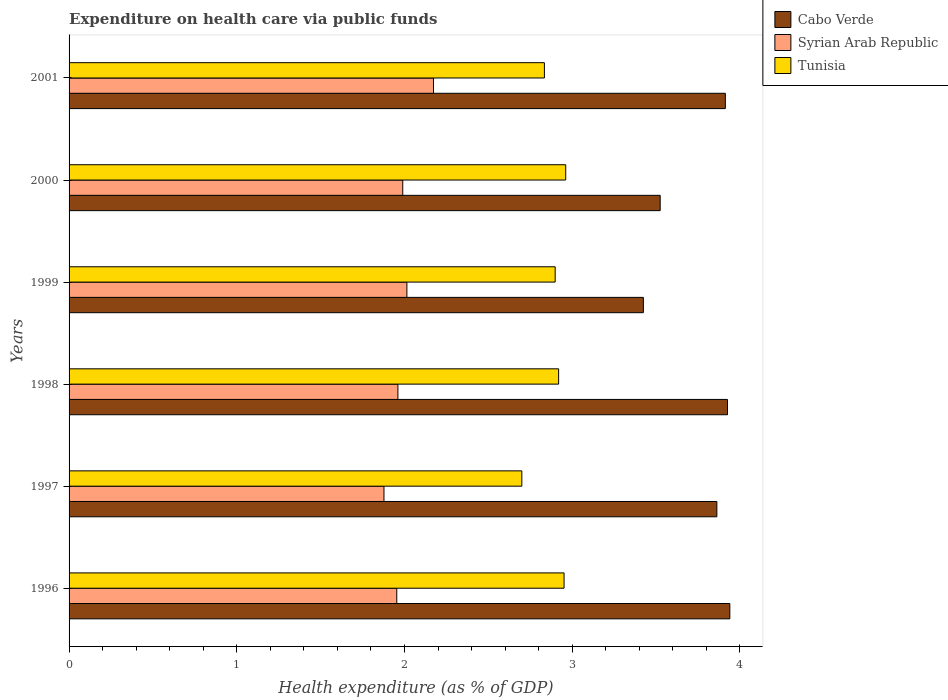How many different coloured bars are there?
Your answer should be very brief. 3. How many bars are there on the 1st tick from the top?
Your response must be concise. 3. How many bars are there on the 2nd tick from the bottom?
Offer a terse response. 3. What is the label of the 1st group of bars from the top?
Your answer should be compact. 2001. In how many cases, is the number of bars for a given year not equal to the number of legend labels?
Offer a very short reply. 0. What is the expenditure made on health care in Syrian Arab Republic in 2000?
Your response must be concise. 1.99. Across all years, what is the maximum expenditure made on health care in Tunisia?
Your response must be concise. 2.96. Across all years, what is the minimum expenditure made on health care in Tunisia?
Offer a terse response. 2.7. In which year was the expenditure made on health care in Cabo Verde maximum?
Ensure brevity in your answer.  1996. What is the total expenditure made on health care in Tunisia in the graph?
Provide a short and direct response. 17.27. What is the difference between the expenditure made on health care in Cabo Verde in 2000 and that in 2001?
Offer a very short reply. -0.39. What is the difference between the expenditure made on health care in Syrian Arab Republic in 2000 and the expenditure made on health care in Cabo Verde in 2001?
Offer a very short reply. -1.92. What is the average expenditure made on health care in Cabo Verde per year?
Your response must be concise. 3.77. In the year 2001, what is the difference between the expenditure made on health care in Cabo Verde and expenditure made on health care in Syrian Arab Republic?
Offer a terse response. 1.74. What is the ratio of the expenditure made on health care in Tunisia in 1996 to that in 1999?
Offer a terse response. 1.02. Is the difference between the expenditure made on health care in Cabo Verde in 1996 and 2000 greater than the difference between the expenditure made on health care in Syrian Arab Republic in 1996 and 2000?
Keep it short and to the point. Yes. What is the difference between the highest and the second highest expenditure made on health care in Tunisia?
Provide a succinct answer. 0.01. What is the difference between the highest and the lowest expenditure made on health care in Syrian Arab Republic?
Give a very brief answer. 0.3. What does the 2nd bar from the top in 1998 represents?
Make the answer very short. Syrian Arab Republic. What does the 3rd bar from the bottom in 2000 represents?
Offer a terse response. Tunisia. What is the difference between two consecutive major ticks on the X-axis?
Your answer should be compact. 1. Are the values on the major ticks of X-axis written in scientific E-notation?
Provide a short and direct response. No. Does the graph contain any zero values?
Provide a succinct answer. No. Where does the legend appear in the graph?
Offer a very short reply. Top right. How many legend labels are there?
Offer a terse response. 3. How are the legend labels stacked?
Offer a terse response. Vertical. What is the title of the graph?
Provide a short and direct response. Expenditure on health care via public funds. What is the label or title of the X-axis?
Provide a succinct answer. Health expenditure (as % of GDP). What is the label or title of the Y-axis?
Your answer should be very brief. Years. What is the Health expenditure (as % of GDP) in Cabo Verde in 1996?
Offer a very short reply. 3.94. What is the Health expenditure (as % of GDP) of Syrian Arab Republic in 1996?
Provide a succinct answer. 1.95. What is the Health expenditure (as % of GDP) of Tunisia in 1996?
Your answer should be very brief. 2.95. What is the Health expenditure (as % of GDP) of Cabo Verde in 1997?
Ensure brevity in your answer.  3.86. What is the Health expenditure (as % of GDP) of Syrian Arab Republic in 1997?
Offer a very short reply. 1.88. What is the Health expenditure (as % of GDP) in Tunisia in 1997?
Give a very brief answer. 2.7. What is the Health expenditure (as % of GDP) of Cabo Verde in 1998?
Make the answer very short. 3.93. What is the Health expenditure (as % of GDP) in Syrian Arab Republic in 1998?
Give a very brief answer. 1.96. What is the Health expenditure (as % of GDP) in Tunisia in 1998?
Offer a terse response. 2.92. What is the Health expenditure (as % of GDP) of Cabo Verde in 1999?
Offer a very short reply. 3.42. What is the Health expenditure (as % of GDP) in Syrian Arab Republic in 1999?
Your answer should be compact. 2.01. What is the Health expenditure (as % of GDP) of Tunisia in 1999?
Offer a terse response. 2.9. What is the Health expenditure (as % of GDP) in Cabo Verde in 2000?
Make the answer very short. 3.52. What is the Health expenditure (as % of GDP) in Syrian Arab Republic in 2000?
Your response must be concise. 1.99. What is the Health expenditure (as % of GDP) in Tunisia in 2000?
Your answer should be very brief. 2.96. What is the Health expenditure (as % of GDP) in Cabo Verde in 2001?
Provide a succinct answer. 3.91. What is the Health expenditure (as % of GDP) of Syrian Arab Republic in 2001?
Provide a succinct answer. 2.17. What is the Health expenditure (as % of GDP) of Tunisia in 2001?
Your response must be concise. 2.83. Across all years, what is the maximum Health expenditure (as % of GDP) in Cabo Verde?
Your response must be concise. 3.94. Across all years, what is the maximum Health expenditure (as % of GDP) in Syrian Arab Republic?
Give a very brief answer. 2.17. Across all years, what is the maximum Health expenditure (as % of GDP) of Tunisia?
Ensure brevity in your answer.  2.96. Across all years, what is the minimum Health expenditure (as % of GDP) of Cabo Verde?
Ensure brevity in your answer.  3.42. Across all years, what is the minimum Health expenditure (as % of GDP) of Syrian Arab Republic?
Offer a very short reply. 1.88. Across all years, what is the minimum Health expenditure (as % of GDP) of Tunisia?
Provide a succinct answer. 2.7. What is the total Health expenditure (as % of GDP) in Cabo Verde in the graph?
Your response must be concise. 22.59. What is the total Health expenditure (as % of GDP) of Syrian Arab Republic in the graph?
Ensure brevity in your answer.  11.97. What is the total Health expenditure (as % of GDP) of Tunisia in the graph?
Provide a short and direct response. 17.27. What is the difference between the Health expenditure (as % of GDP) of Cabo Verde in 1996 and that in 1997?
Offer a terse response. 0.08. What is the difference between the Health expenditure (as % of GDP) of Syrian Arab Republic in 1996 and that in 1997?
Your answer should be very brief. 0.08. What is the difference between the Health expenditure (as % of GDP) in Tunisia in 1996 and that in 1997?
Make the answer very short. 0.25. What is the difference between the Health expenditure (as % of GDP) in Cabo Verde in 1996 and that in 1998?
Keep it short and to the point. 0.01. What is the difference between the Health expenditure (as % of GDP) of Syrian Arab Republic in 1996 and that in 1998?
Offer a very short reply. -0.01. What is the difference between the Health expenditure (as % of GDP) of Tunisia in 1996 and that in 1998?
Your answer should be very brief. 0.03. What is the difference between the Health expenditure (as % of GDP) in Cabo Verde in 1996 and that in 1999?
Your response must be concise. 0.52. What is the difference between the Health expenditure (as % of GDP) in Syrian Arab Republic in 1996 and that in 1999?
Offer a very short reply. -0.06. What is the difference between the Health expenditure (as % of GDP) in Tunisia in 1996 and that in 1999?
Offer a very short reply. 0.05. What is the difference between the Health expenditure (as % of GDP) in Cabo Verde in 1996 and that in 2000?
Give a very brief answer. 0.42. What is the difference between the Health expenditure (as % of GDP) in Syrian Arab Republic in 1996 and that in 2000?
Your response must be concise. -0.04. What is the difference between the Health expenditure (as % of GDP) of Tunisia in 1996 and that in 2000?
Provide a succinct answer. -0.01. What is the difference between the Health expenditure (as % of GDP) in Cabo Verde in 1996 and that in 2001?
Offer a very short reply. 0.03. What is the difference between the Health expenditure (as % of GDP) of Syrian Arab Republic in 1996 and that in 2001?
Your response must be concise. -0.22. What is the difference between the Health expenditure (as % of GDP) of Tunisia in 1996 and that in 2001?
Ensure brevity in your answer.  0.12. What is the difference between the Health expenditure (as % of GDP) in Cabo Verde in 1997 and that in 1998?
Ensure brevity in your answer.  -0.06. What is the difference between the Health expenditure (as % of GDP) in Syrian Arab Republic in 1997 and that in 1998?
Your response must be concise. -0.08. What is the difference between the Health expenditure (as % of GDP) of Tunisia in 1997 and that in 1998?
Make the answer very short. -0.22. What is the difference between the Health expenditure (as % of GDP) of Cabo Verde in 1997 and that in 1999?
Your response must be concise. 0.44. What is the difference between the Health expenditure (as % of GDP) in Syrian Arab Republic in 1997 and that in 1999?
Give a very brief answer. -0.14. What is the difference between the Health expenditure (as % of GDP) in Tunisia in 1997 and that in 1999?
Ensure brevity in your answer.  -0.2. What is the difference between the Health expenditure (as % of GDP) of Cabo Verde in 1997 and that in 2000?
Give a very brief answer. 0.34. What is the difference between the Health expenditure (as % of GDP) in Syrian Arab Republic in 1997 and that in 2000?
Your response must be concise. -0.11. What is the difference between the Health expenditure (as % of GDP) of Tunisia in 1997 and that in 2000?
Your answer should be compact. -0.26. What is the difference between the Health expenditure (as % of GDP) of Cabo Verde in 1997 and that in 2001?
Keep it short and to the point. -0.05. What is the difference between the Health expenditure (as % of GDP) of Syrian Arab Republic in 1997 and that in 2001?
Offer a terse response. -0.3. What is the difference between the Health expenditure (as % of GDP) of Tunisia in 1997 and that in 2001?
Provide a succinct answer. -0.13. What is the difference between the Health expenditure (as % of GDP) in Cabo Verde in 1998 and that in 1999?
Your response must be concise. 0.5. What is the difference between the Health expenditure (as % of GDP) in Syrian Arab Republic in 1998 and that in 1999?
Give a very brief answer. -0.05. What is the difference between the Health expenditure (as % of GDP) in Tunisia in 1998 and that in 1999?
Ensure brevity in your answer.  0.02. What is the difference between the Health expenditure (as % of GDP) in Cabo Verde in 1998 and that in 2000?
Keep it short and to the point. 0.4. What is the difference between the Health expenditure (as % of GDP) in Syrian Arab Republic in 1998 and that in 2000?
Offer a very short reply. -0.03. What is the difference between the Health expenditure (as % of GDP) of Tunisia in 1998 and that in 2000?
Your response must be concise. -0.04. What is the difference between the Health expenditure (as % of GDP) of Cabo Verde in 1998 and that in 2001?
Offer a very short reply. 0.01. What is the difference between the Health expenditure (as % of GDP) of Syrian Arab Republic in 1998 and that in 2001?
Offer a very short reply. -0.21. What is the difference between the Health expenditure (as % of GDP) of Tunisia in 1998 and that in 2001?
Your response must be concise. 0.08. What is the difference between the Health expenditure (as % of GDP) of Cabo Verde in 1999 and that in 2000?
Make the answer very short. -0.1. What is the difference between the Health expenditure (as % of GDP) of Syrian Arab Republic in 1999 and that in 2000?
Offer a very short reply. 0.02. What is the difference between the Health expenditure (as % of GDP) in Tunisia in 1999 and that in 2000?
Keep it short and to the point. -0.06. What is the difference between the Health expenditure (as % of GDP) of Cabo Verde in 1999 and that in 2001?
Your answer should be compact. -0.49. What is the difference between the Health expenditure (as % of GDP) of Syrian Arab Republic in 1999 and that in 2001?
Your answer should be compact. -0.16. What is the difference between the Health expenditure (as % of GDP) in Tunisia in 1999 and that in 2001?
Provide a succinct answer. 0.06. What is the difference between the Health expenditure (as % of GDP) in Cabo Verde in 2000 and that in 2001?
Your answer should be compact. -0.39. What is the difference between the Health expenditure (as % of GDP) of Syrian Arab Republic in 2000 and that in 2001?
Make the answer very short. -0.18. What is the difference between the Health expenditure (as % of GDP) in Tunisia in 2000 and that in 2001?
Give a very brief answer. 0.13. What is the difference between the Health expenditure (as % of GDP) of Cabo Verde in 1996 and the Health expenditure (as % of GDP) of Syrian Arab Republic in 1997?
Your response must be concise. 2.06. What is the difference between the Health expenditure (as % of GDP) of Cabo Verde in 1996 and the Health expenditure (as % of GDP) of Tunisia in 1997?
Keep it short and to the point. 1.24. What is the difference between the Health expenditure (as % of GDP) of Syrian Arab Republic in 1996 and the Health expenditure (as % of GDP) of Tunisia in 1997?
Provide a short and direct response. -0.75. What is the difference between the Health expenditure (as % of GDP) of Cabo Verde in 1996 and the Health expenditure (as % of GDP) of Syrian Arab Republic in 1998?
Provide a short and direct response. 1.98. What is the difference between the Health expenditure (as % of GDP) of Cabo Verde in 1996 and the Health expenditure (as % of GDP) of Tunisia in 1998?
Your response must be concise. 1.02. What is the difference between the Health expenditure (as % of GDP) of Syrian Arab Republic in 1996 and the Health expenditure (as % of GDP) of Tunisia in 1998?
Offer a very short reply. -0.97. What is the difference between the Health expenditure (as % of GDP) in Cabo Verde in 1996 and the Health expenditure (as % of GDP) in Syrian Arab Republic in 1999?
Your response must be concise. 1.93. What is the difference between the Health expenditure (as % of GDP) of Cabo Verde in 1996 and the Health expenditure (as % of GDP) of Tunisia in 1999?
Your response must be concise. 1.04. What is the difference between the Health expenditure (as % of GDP) in Syrian Arab Republic in 1996 and the Health expenditure (as % of GDP) in Tunisia in 1999?
Your answer should be very brief. -0.94. What is the difference between the Health expenditure (as % of GDP) of Cabo Verde in 1996 and the Health expenditure (as % of GDP) of Syrian Arab Republic in 2000?
Your answer should be compact. 1.95. What is the difference between the Health expenditure (as % of GDP) in Cabo Verde in 1996 and the Health expenditure (as % of GDP) in Tunisia in 2000?
Provide a short and direct response. 0.98. What is the difference between the Health expenditure (as % of GDP) in Syrian Arab Republic in 1996 and the Health expenditure (as % of GDP) in Tunisia in 2000?
Offer a very short reply. -1.01. What is the difference between the Health expenditure (as % of GDP) in Cabo Verde in 1996 and the Health expenditure (as % of GDP) in Syrian Arab Republic in 2001?
Your response must be concise. 1.77. What is the difference between the Health expenditure (as % of GDP) in Cabo Verde in 1996 and the Health expenditure (as % of GDP) in Tunisia in 2001?
Provide a short and direct response. 1.11. What is the difference between the Health expenditure (as % of GDP) in Syrian Arab Republic in 1996 and the Health expenditure (as % of GDP) in Tunisia in 2001?
Make the answer very short. -0.88. What is the difference between the Health expenditure (as % of GDP) of Cabo Verde in 1997 and the Health expenditure (as % of GDP) of Syrian Arab Republic in 1998?
Ensure brevity in your answer.  1.9. What is the difference between the Health expenditure (as % of GDP) of Cabo Verde in 1997 and the Health expenditure (as % of GDP) of Tunisia in 1998?
Keep it short and to the point. 0.94. What is the difference between the Health expenditure (as % of GDP) of Syrian Arab Republic in 1997 and the Health expenditure (as % of GDP) of Tunisia in 1998?
Offer a very short reply. -1.04. What is the difference between the Health expenditure (as % of GDP) in Cabo Verde in 1997 and the Health expenditure (as % of GDP) in Syrian Arab Republic in 1999?
Make the answer very short. 1.85. What is the difference between the Health expenditure (as % of GDP) in Cabo Verde in 1997 and the Health expenditure (as % of GDP) in Tunisia in 1999?
Your answer should be compact. 0.96. What is the difference between the Health expenditure (as % of GDP) in Syrian Arab Republic in 1997 and the Health expenditure (as % of GDP) in Tunisia in 1999?
Your response must be concise. -1.02. What is the difference between the Health expenditure (as % of GDP) in Cabo Verde in 1997 and the Health expenditure (as % of GDP) in Syrian Arab Republic in 2000?
Provide a succinct answer. 1.87. What is the difference between the Health expenditure (as % of GDP) of Cabo Verde in 1997 and the Health expenditure (as % of GDP) of Tunisia in 2000?
Keep it short and to the point. 0.9. What is the difference between the Health expenditure (as % of GDP) of Syrian Arab Republic in 1997 and the Health expenditure (as % of GDP) of Tunisia in 2000?
Offer a terse response. -1.08. What is the difference between the Health expenditure (as % of GDP) in Cabo Verde in 1997 and the Health expenditure (as % of GDP) in Syrian Arab Republic in 2001?
Ensure brevity in your answer.  1.69. What is the difference between the Health expenditure (as % of GDP) in Cabo Verde in 1997 and the Health expenditure (as % of GDP) in Tunisia in 2001?
Give a very brief answer. 1.03. What is the difference between the Health expenditure (as % of GDP) of Syrian Arab Republic in 1997 and the Health expenditure (as % of GDP) of Tunisia in 2001?
Give a very brief answer. -0.96. What is the difference between the Health expenditure (as % of GDP) in Cabo Verde in 1998 and the Health expenditure (as % of GDP) in Syrian Arab Republic in 1999?
Your response must be concise. 1.91. What is the difference between the Health expenditure (as % of GDP) in Cabo Verde in 1998 and the Health expenditure (as % of GDP) in Tunisia in 1999?
Provide a short and direct response. 1.03. What is the difference between the Health expenditure (as % of GDP) in Syrian Arab Republic in 1998 and the Health expenditure (as % of GDP) in Tunisia in 1999?
Offer a terse response. -0.94. What is the difference between the Health expenditure (as % of GDP) in Cabo Verde in 1998 and the Health expenditure (as % of GDP) in Syrian Arab Republic in 2000?
Provide a short and direct response. 1.94. What is the difference between the Health expenditure (as % of GDP) in Cabo Verde in 1998 and the Health expenditure (as % of GDP) in Tunisia in 2000?
Your answer should be compact. 0.96. What is the difference between the Health expenditure (as % of GDP) of Syrian Arab Republic in 1998 and the Health expenditure (as % of GDP) of Tunisia in 2000?
Give a very brief answer. -1. What is the difference between the Health expenditure (as % of GDP) in Cabo Verde in 1998 and the Health expenditure (as % of GDP) in Syrian Arab Republic in 2001?
Offer a very short reply. 1.75. What is the difference between the Health expenditure (as % of GDP) of Cabo Verde in 1998 and the Health expenditure (as % of GDP) of Tunisia in 2001?
Offer a terse response. 1.09. What is the difference between the Health expenditure (as % of GDP) in Syrian Arab Republic in 1998 and the Health expenditure (as % of GDP) in Tunisia in 2001?
Make the answer very short. -0.87. What is the difference between the Health expenditure (as % of GDP) in Cabo Verde in 1999 and the Health expenditure (as % of GDP) in Syrian Arab Republic in 2000?
Provide a short and direct response. 1.43. What is the difference between the Health expenditure (as % of GDP) of Cabo Verde in 1999 and the Health expenditure (as % of GDP) of Tunisia in 2000?
Your answer should be compact. 0.46. What is the difference between the Health expenditure (as % of GDP) of Syrian Arab Republic in 1999 and the Health expenditure (as % of GDP) of Tunisia in 2000?
Keep it short and to the point. -0.95. What is the difference between the Health expenditure (as % of GDP) in Cabo Verde in 1999 and the Health expenditure (as % of GDP) in Syrian Arab Republic in 2001?
Offer a very short reply. 1.25. What is the difference between the Health expenditure (as % of GDP) of Cabo Verde in 1999 and the Health expenditure (as % of GDP) of Tunisia in 2001?
Make the answer very short. 0.59. What is the difference between the Health expenditure (as % of GDP) of Syrian Arab Republic in 1999 and the Health expenditure (as % of GDP) of Tunisia in 2001?
Provide a succinct answer. -0.82. What is the difference between the Health expenditure (as % of GDP) in Cabo Verde in 2000 and the Health expenditure (as % of GDP) in Syrian Arab Republic in 2001?
Give a very brief answer. 1.35. What is the difference between the Health expenditure (as % of GDP) of Cabo Verde in 2000 and the Health expenditure (as % of GDP) of Tunisia in 2001?
Offer a very short reply. 0.69. What is the difference between the Health expenditure (as % of GDP) in Syrian Arab Republic in 2000 and the Health expenditure (as % of GDP) in Tunisia in 2001?
Offer a very short reply. -0.84. What is the average Health expenditure (as % of GDP) of Cabo Verde per year?
Make the answer very short. 3.77. What is the average Health expenditure (as % of GDP) of Syrian Arab Republic per year?
Your answer should be compact. 2. What is the average Health expenditure (as % of GDP) in Tunisia per year?
Make the answer very short. 2.88. In the year 1996, what is the difference between the Health expenditure (as % of GDP) in Cabo Verde and Health expenditure (as % of GDP) in Syrian Arab Republic?
Offer a very short reply. 1.99. In the year 1996, what is the difference between the Health expenditure (as % of GDP) of Cabo Verde and Health expenditure (as % of GDP) of Tunisia?
Give a very brief answer. 0.99. In the year 1996, what is the difference between the Health expenditure (as % of GDP) of Syrian Arab Republic and Health expenditure (as % of GDP) of Tunisia?
Keep it short and to the point. -1. In the year 1997, what is the difference between the Health expenditure (as % of GDP) in Cabo Verde and Health expenditure (as % of GDP) in Syrian Arab Republic?
Provide a short and direct response. 1.99. In the year 1997, what is the difference between the Health expenditure (as % of GDP) of Cabo Verde and Health expenditure (as % of GDP) of Tunisia?
Keep it short and to the point. 1.16. In the year 1997, what is the difference between the Health expenditure (as % of GDP) of Syrian Arab Republic and Health expenditure (as % of GDP) of Tunisia?
Make the answer very short. -0.82. In the year 1998, what is the difference between the Health expenditure (as % of GDP) in Cabo Verde and Health expenditure (as % of GDP) in Syrian Arab Republic?
Make the answer very short. 1.97. In the year 1998, what is the difference between the Health expenditure (as % of GDP) of Syrian Arab Republic and Health expenditure (as % of GDP) of Tunisia?
Give a very brief answer. -0.96. In the year 1999, what is the difference between the Health expenditure (as % of GDP) of Cabo Verde and Health expenditure (as % of GDP) of Syrian Arab Republic?
Give a very brief answer. 1.41. In the year 1999, what is the difference between the Health expenditure (as % of GDP) of Cabo Verde and Health expenditure (as % of GDP) of Tunisia?
Keep it short and to the point. 0.53. In the year 1999, what is the difference between the Health expenditure (as % of GDP) in Syrian Arab Republic and Health expenditure (as % of GDP) in Tunisia?
Offer a terse response. -0.88. In the year 2000, what is the difference between the Health expenditure (as % of GDP) in Cabo Verde and Health expenditure (as % of GDP) in Syrian Arab Republic?
Ensure brevity in your answer.  1.54. In the year 2000, what is the difference between the Health expenditure (as % of GDP) of Cabo Verde and Health expenditure (as % of GDP) of Tunisia?
Make the answer very short. 0.56. In the year 2000, what is the difference between the Health expenditure (as % of GDP) of Syrian Arab Republic and Health expenditure (as % of GDP) of Tunisia?
Provide a short and direct response. -0.97. In the year 2001, what is the difference between the Health expenditure (as % of GDP) in Cabo Verde and Health expenditure (as % of GDP) in Syrian Arab Republic?
Offer a very short reply. 1.74. In the year 2001, what is the difference between the Health expenditure (as % of GDP) of Cabo Verde and Health expenditure (as % of GDP) of Tunisia?
Ensure brevity in your answer.  1.08. In the year 2001, what is the difference between the Health expenditure (as % of GDP) of Syrian Arab Republic and Health expenditure (as % of GDP) of Tunisia?
Provide a short and direct response. -0.66. What is the ratio of the Health expenditure (as % of GDP) of Cabo Verde in 1996 to that in 1997?
Keep it short and to the point. 1.02. What is the ratio of the Health expenditure (as % of GDP) of Syrian Arab Republic in 1996 to that in 1997?
Offer a terse response. 1.04. What is the ratio of the Health expenditure (as % of GDP) of Tunisia in 1996 to that in 1997?
Ensure brevity in your answer.  1.09. What is the ratio of the Health expenditure (as % of GDP) in Tunisia in 1996 to that in 1998?
Offer a terse response. 1.01. What is the ratio of the Health expenditure (as % of GDP) of Cabo Verde in 1996 to that in 1999?
Provide a short and direct response. 1.15. What is the ratio of the Health expenditure (as % of GDP) in Syrian Arab Republic in 1996 to that in 1999?
Offer a terse response. 0.97. What is the ratio of the Health expenditure (as % of GDP) of Tunisia in 1996 to that in 1999?
Offer a very short reply. 1.02. What is the ratio of the Health expenditure (as % of GDP) of Cabo Verde in 1996 to that in 2000?
Offer a very short reply. 1.12. What is the ratio of the Health expenditure (as % of GDP) of Syrian Arab Republic in 1996 to that in 2000?
Give a very brief answer. 0.98. What is the ratio of the Health expenditure (as % of GDP) of Cabo Verde in 1996 to that in 2001?
Keep it short and to the point. 1.01. What is the ratio of the Health expenditure (as % of GDP) in Syrian Arab Republic in 1996 to that in 2001?
Provide a succinct answer. 0.9. What is the ratio of the Health expenditure (as % of GDP) in Tunisia in 1996 to that in 2001?
Offer a terse response. 1.04. What is the ratio of the Health expenditure (as % of GDP) of Cabo Verde in 1997 to that in 1998?
Your response must be concise. 0.98. What is the ratio of the Health expenditure (as % of GDP) in Syrian Arab Republic in 1997 to that in 1998?
Your answer should be compact. 0.96. What is the ratio of the Health expenditure (as % of GDP) in Tunisia in 1997 to that in 1998?
Your response must be concise. 0.92. What is the ratio of the Health expenditure (as % of GDP) in Cabo Verde in 1997 to that in 1999?
Your answer should be compact. 1.13. What is the ratio of the Health expenditure (as % of GDP) in Syrian Arab Republic in 1997 to that in 1999?
Provide a short and direct response. 0.93. What is the ratio of the Health expenditure (as % of GDP) of Tunisia in 1997 to that in 1999?
Make the answer very short. 0.93. What is the ratio of the Health expenditure (as % of GDP) of Cabo Verde in 1997 to that in 2000?
Your answer should be very brief. 1.1. What is the ratio of the Health expenditure (as % of GDP) in Syrian Arab Republic in 1997 to that in 2000?
Offer a terse response. 0.94. What is the ratio of the Health expenditure (as % of GDP) in Tunisia in 1997 to that in 2000?
Your answer should be very brief. 0.91. What is the ratio of the Health expenditure (as % of GDP) of Cabo Verde in 1997 to that in 2001?
Your response must be concise. 0.99. What is the ratio of the Health expenditure (as % of GDP) of Syrian Arab Republic in 1997 to that in 2001?
Ensure brevity in your answer.  0.86. What is the ratio of the Health expenditure (as % of GDP) of Tunisia in 1997 to that in 2001?
Give a very brief answer. 0.95. What is the ratio of the Health expenditure (as % of GDP) in Cabo Verde in 1998 to that in 1999?
Provide a succinct answer. 1.15. What is the ratio of the Health expenditure (as % of GDP) in Syrian Arab Republic in 1998 to that in 1999?
Keep it short and to the point. 0.97. What is the ratio of the Health expenditure (as % of GDP) of Tunisia in 1998 to that in 1999?
Offer a terse response. 1.01. What is the ratio of the Health expenditure (as % of GDP) in Cabo Verde in 1998 to that in 2000?
Your answer should be compact. 1.11. What is the ratio of the Health expenditure (as % of GDP) in Syrian Arab Republic in 1998 to that in 2000?
Ensure brevity in your answer.  0.99. What is the ratio of the Health expenditure (as % of GDP) of Tunisia in 1998 to that in 2000?
Your response must be concise. 0.99. What is the ratio of the Health expenditure (as % of GDP) in Cabo Verde in 1998 to that in 2001?
Give a very brief answer. 1. What is the ratio of the Health expenditure (as % of GDP) in Syrian Arab Republic in 1998 to that in 2001?
Your answer should be compact. 0.9. What is the ratio of the Health expenditure (as % of GDP) in Tunisia in 1998 to that in 2001?
Provide a succinct answer. 1.03. What is the ratio of the Health expenditure (as % of GDP) of Cabo Verde in 1999 to that in 2000?
Your answer should be compact. 0.97. What is the ratio of the Health expenditure (as % of GDP) of Syrian Arab Republic in 1999 to that in 2000?
Provide a short and direct response. 1.01. What is the ratio of the Health expenditure (as % of GDP) in Tunisia in 1999 to that in 2000?
Make the answer very short. 0.98. What is the ratio of the Health expenditure (as % of GDP) of Cabo Verde in 1999 to that in 2001?
Keep it short and to the point. 0.88. What is the ratio of the Health expenditure (as % of GDP) in Syrian Arab Republic in 1999 to that in 2001?
Your answer should be compact. 0.93. What is the ratio of the Health expenditure (as % of GDP) of Tunisia in 1999 to that in 2001?
Your answer should be compact. 1.02. What is the ratio of the Health expenditure (as % of GDP) of Cabo Verde in 2000 to that in 2001?
Offer a very short reply. 0.9. What is the ratio of the Health expenditure (as % of GDP) in Syrian Arab Republic in 2000 to that in 2001?
Give a very brief answer. 0.92. What is the ratio of the Health expenditure (as % of GDP) in Tunisia in 2000 to that in 2001?
Provide a short and direct response. 1.04. What is the difference between the highest and the second highest Health expenditure (as % of GDP) in Cabo Verde?
Your response must be concise. 0.01. What is the difference between the highest and the second highest Health expenditure (as % of GDP) in Syrian Arab Republic?
Offer a terse response. 0.16. What is the difference between the highest and the second highest Health expenditure (as % of GDP) in Tunisia?
Ensure brevity in your answer.  0.01. What is the difference between the highest and the lowest Health expenditure (as % of GDP) of Cabo Verde?
Offer a terse response. 0.52. What is the difference between the highest and the lowest Health expenditure (as % of GDP) of Syrian Arab Republic?
Give a very brief answer. 0.3. What is the difference between the highest and the lowest Health expenditure (as % of GDP) in Tunisia?
Offer a very short reply. 0.26. 